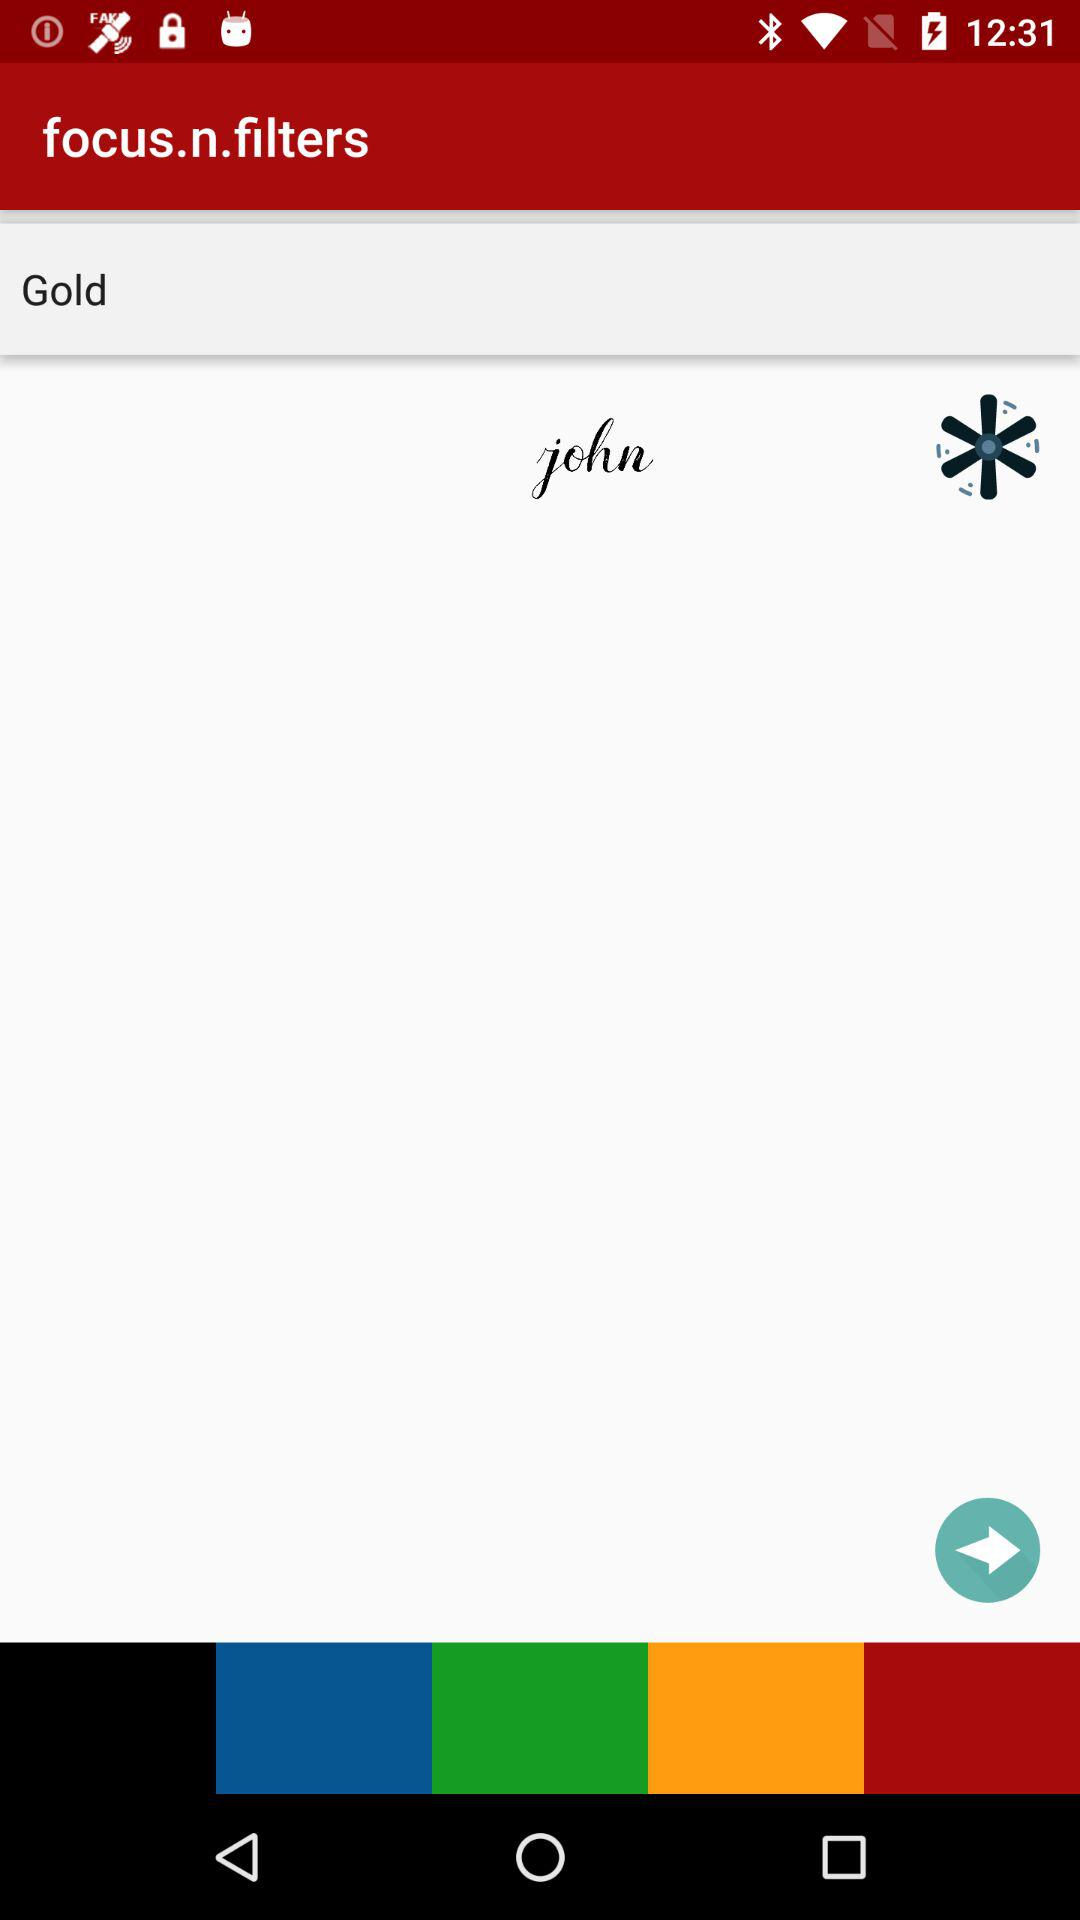What is the user name? The user name is John. 